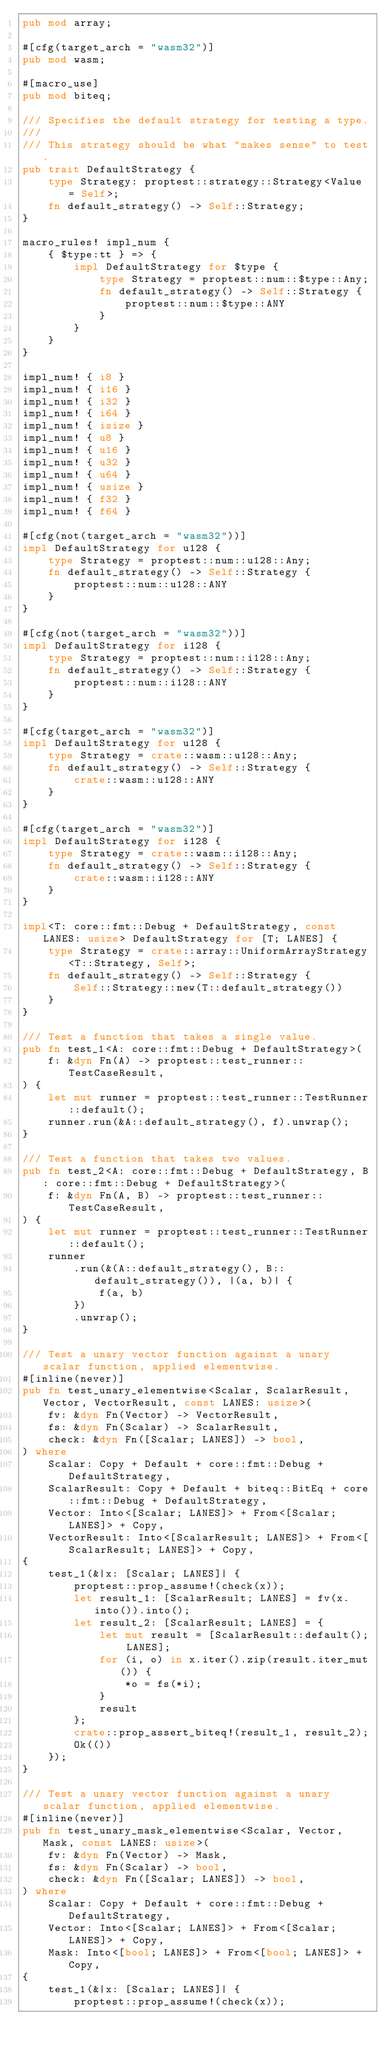Convert code to text. <code><loc_0><loc_0><loc_500><loc_500><_Rust_>pub mod array;

#[cfg(target_arch = "wasm32")]
pub mod wasm;

#[macro_use]
pub mod biteq;

/// Specifies the default strategy for testing a type.
///
/// This strategy should be what "makes sense" to test.
pub trait DefaultStrategy {
    type Strategy: proptest::strategy::Strategy<Value = Self>;
    fn default_strategy() -> Self::Strategy;
}

macro_rules! impl_num {
    { $type:tt } => {
        impl DefaultStrategy for $type {
            type Strategy = proptest::num::$type::Any;
            fn default_strategy() -> Self::Strategy {
                proptest::num::$type::ANY
            }
        }
    }
}

impl_num! { i8 }
impl_num! { i16 }
impl_num! { i32 }
impl_num! { i64 }
impl_num! { isize }
impl_num! { u8 }
impl_num! { u16 }
impl_num! { u32 }
impl_num! { u64 }
impl_num! { usize }
impl_num! { f32 }
impl_num! { f64 }

#[cfg(not(target_arch = "wasm32"))]
impl DefaultStrategy for u128 {
    type Strategy = proptest::num::u128::Any;
    fn default_strategy() -> Self::Strategy {
        proptest::num::u128::ANY
    }
}

#[cfg(not(target_arch = "wasm32"))]
impl DefaultStrategy for i128 {
    type Strategy = proptest::num::i128::Any;
    fn default_strategy() -> Self::Strategy {
        proptest::num::i128::ANY
    }
}

#[cfg(target_arch = "wasm32")]
impl DefaultStrategy for u128 {
    type Strategy = crate::wasm::u128::Any;
    fn default_strategy() -> Self::Strategy {
        crate::wasm::u128::ANY
    }
}

#[cfg(target_arch = "wasm32")]
impl DefaultStrategy for i128 {
    type Strategy = crate::wasm::i128::Any;
    fn default_strategy() -> Self::Strategy {
        crate::wasm::i128::ANY
    }
}

impl<T: core::fmt::Debug + DefaultStrategy, const LANES: usize> DefaultStrategy for [T; LANES] {
    type Strategy = crate::array::UniformArrayStrategy<T::Strategy, Self>;
    fn default_strategy() -> Self::Strategy {
        Self::Strategy::new(T::default_strategy())
    }
}

/// Test a function that takes a single value.
pub fn test_1<A: core::fmt::Debug + DefaultStrategy>(
    f: &dyn Fn(A) -> proptest::test_runner::TestCaseResult,
) {
    let mut runner = proptest::test_runner::TestRunner::default();
    runner.run(&A::default_strategy(), f).unwrap();
}

/// Test a function that takes two values.
pub fn test_2<A: core::fmt::Debug + DefaultStrategy, B: core::fmt::Debug + DefaultStrategy>(
    f: &dyn Fn(A, B) -> proptest::test_runner::TestCaseResult,
) {
    let mut runner = proptest::test_runner::TestRunner::default();
    runner
        .run(&(A::default_strategy(), B::default_strategy()), |(a, b)| {
            f(a, b)
        })
        .unwrap();
}

/// Test a unary vector function against a unary scalar function, applied elementwise.
#[inline(never)]
pub fn test_unary_elementwise<Scalar, ScalarResult, Vector, VectorResult, const LANES: usize>(
    fv: &dyn Fn(Vector) -> VectorResult,
    fs: &dyn Fn(Scalar) -> ScalarResult,
    check: &dyn Fn([Scalar; LANES]) -> bool,
) where
    Scalar: Copy + Default + core::fmt::Debug + DefaultStrategy,
    ScalarResult: Copy + Default + biteq::BitEq + core::fmt::Debug + DefaultStrategy,
    Vector: Into<[Scalar; LANES]> + From<[Scalar; LANES]> + Copy,
    VectorResult: Into<[ScalarResult; LANES]> + From<[ScalarResult; LANES]> + Copy,
{
    test_1(&|x: [Scalar; LANES]| {
        proptest::prop_assume!(check(x));
        let result_1: [ScalarResult; LANES] = fv(x.into()).into();
        let result_2: [ScalarResult; LANES] = {
            let mut result = [ScalarResult::default(); LANES];
            for (i, o) in x.iter().zip(result.iter_mut()) {
                *o = fs(*i);
            }
            result
        };
        crate::prop_assert_biteq!(result_1, result_2);
        Ok(())
    });
}

/// Test a unary vector function against a unary scalar function, applied elementwise.
#[inline(never)]
pub fn test_unary_mask_elementwise<Scalar, Vector, Mask, const LANES: usize>(
    fv: &dyn Fn(Vector) -> Mask,
    fs: &dyn Fn(Scalar) -> bool,
    check: &dyn Fn([Scalar; LANES]) -> bool,
) where
    Scalar: Copy + Default + core::fmt::Debug + DefaultStrategy,
    Vector: Into<[Scalar; LANES]> + From<[Scalar; LANES]> + Copy,
    Mask: Into<[bool; LANES]> + From<[bool; LANES]> + Copy,
{
    test_1(&|x: [Scalar; LANES]| {
        proptest::prop_assume!(check(x));</code> 